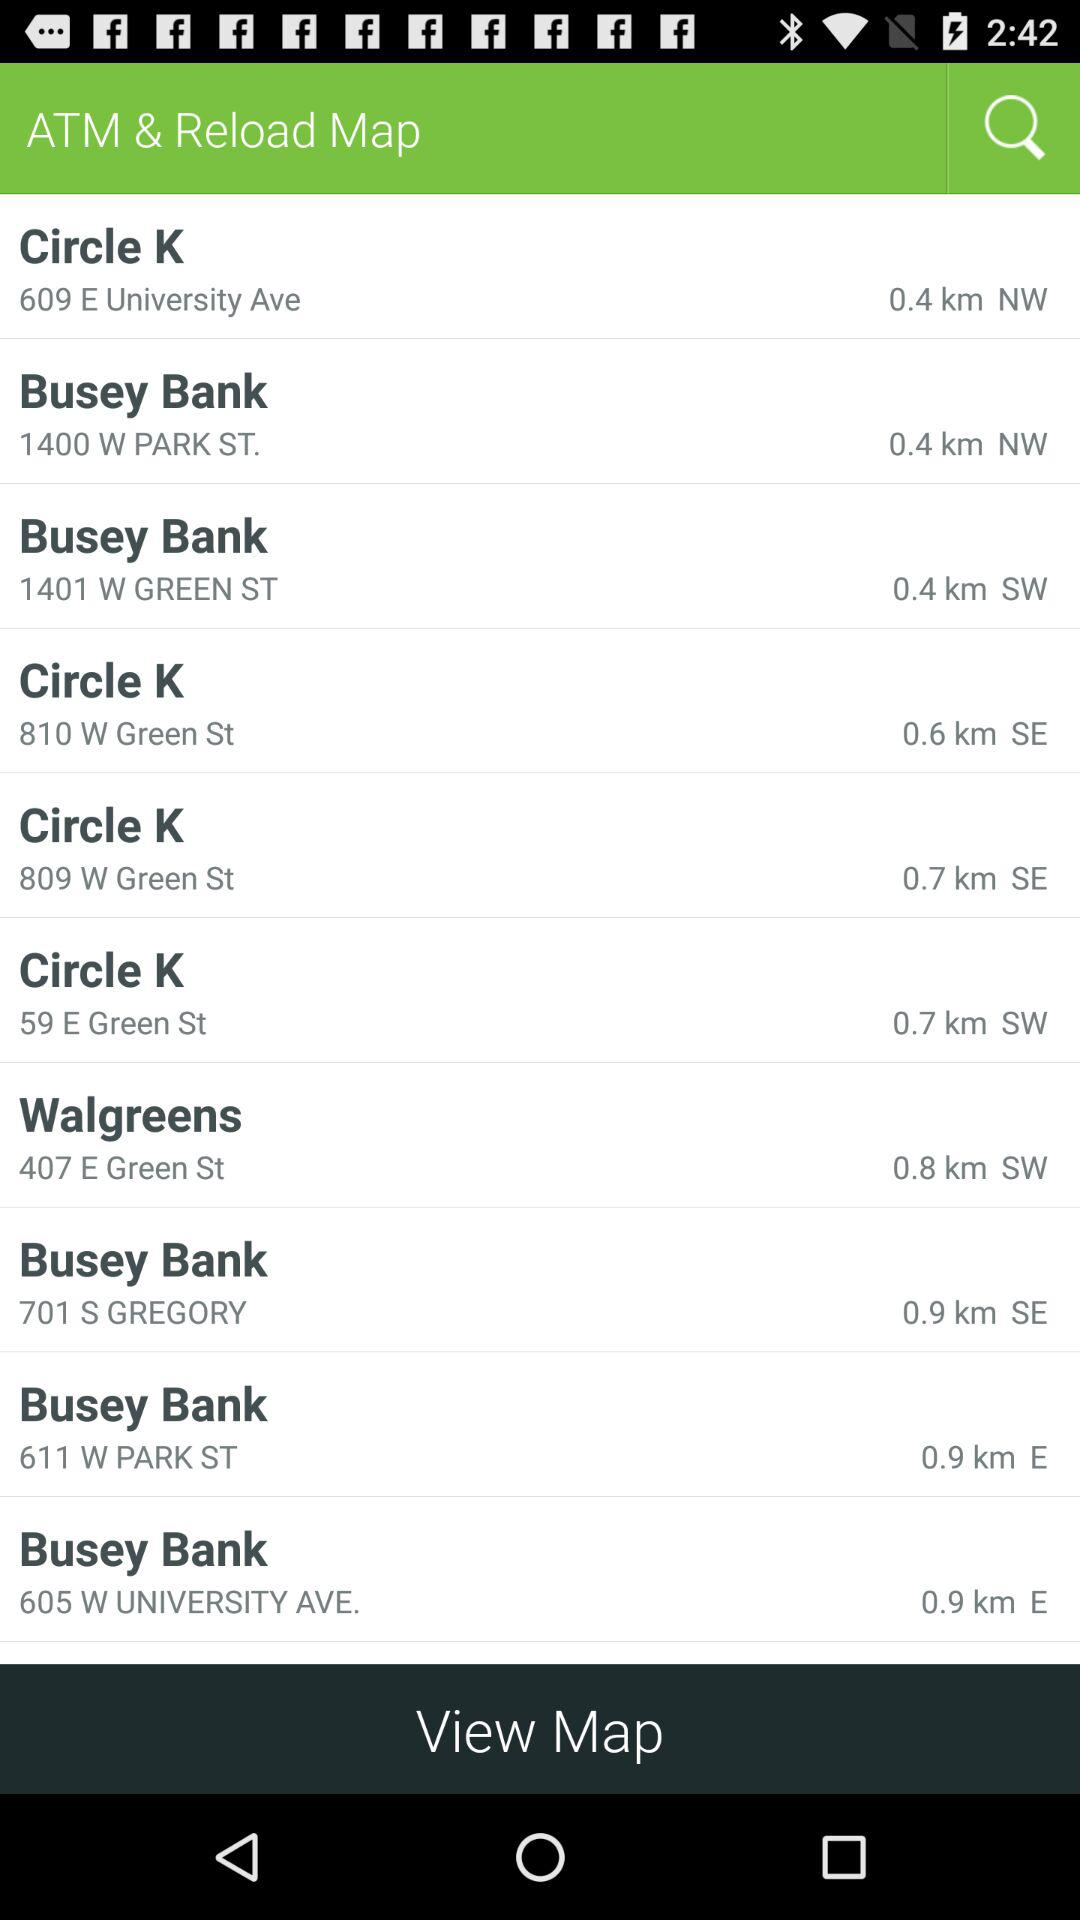What's the address of Walgreens? The address is 407 E. Green St. 